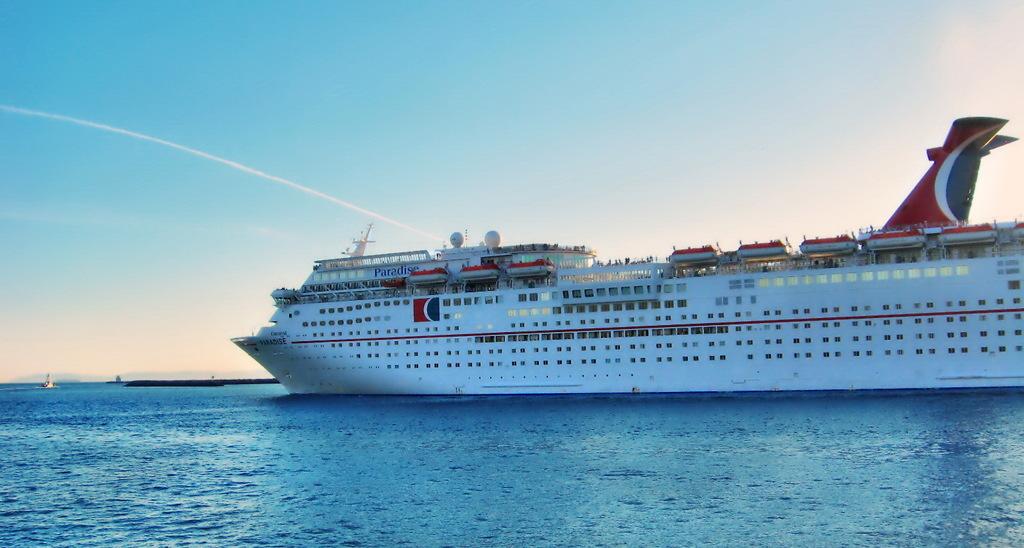What is the first letter in the name of the ship?
Make the answer very short. P. 